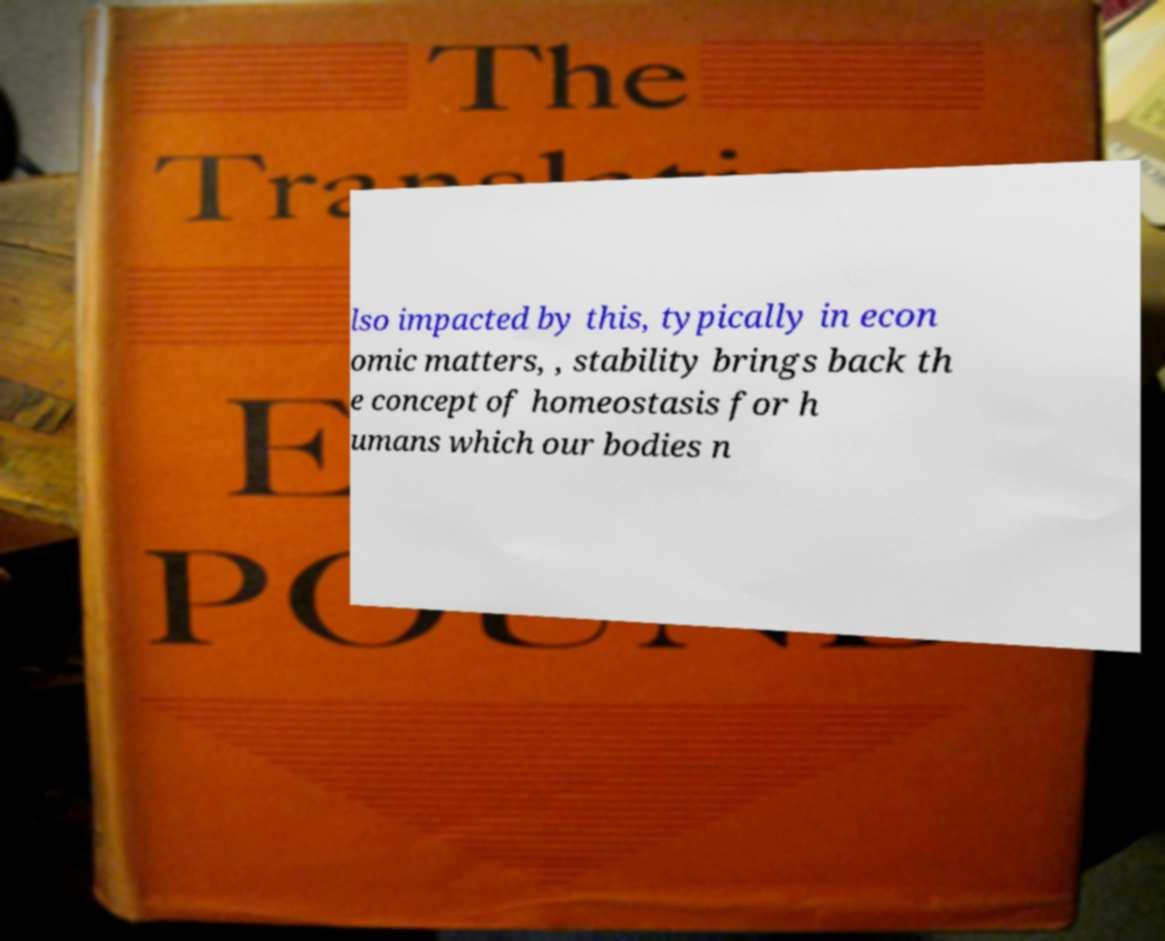There's text embedded in this image that I need extracted. Can you transcribe it verbatim? lso impacted by this, typically in econ omic matters, , stability brings back th e concept of homeostasis for h umans which our bodies n 